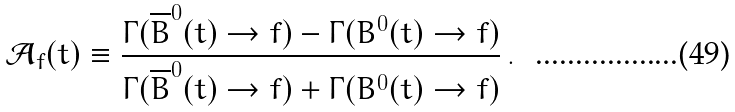<formula> <loc_0><loc_0><loc_500><loc_500>\mathcal { A } _ { f } ( t ) \equiv \frac { \Gamma ( \overline { B } ^ { 0 } ( t ) \to f ) - \Gamma ( B ^ { 0 } ( t ) \to f ) } { \Gamma ( \overline { B } ^ { 0 } ( t ) \to f ) + \Gamma ( B ^ { 0 } ( t ) \to f ) } \, .</formula> 